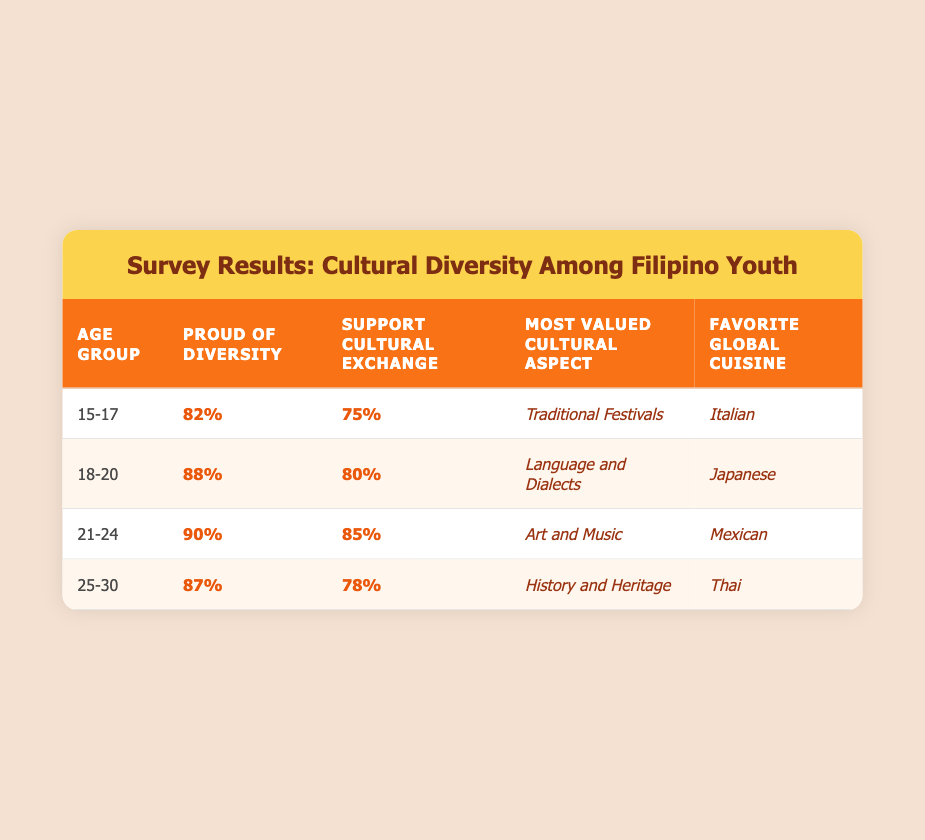What percentage of the 18-20 age group feel proud of diversity? In the table, for the age group 18-20, the corresponding percentage for feeling proud of diversity is listed. It shows 88%.
Answer: 88% What is the most valued cultural aspect among the 21-24 age group? By looking at the row for the 21-24 age group, we find that the most valued cultural aspect is "Art and Music."
Answer: Art and Music What percentage of Filipino youth aged 25-30 support cultural exchange? The table indicates that 78% of the 25-30 age group support cultural exchange.
Answer: 78% Which age group has the highest percentage of youths who feel proud of diversity? When examining the percentages for pride in diversity across all age groups, the 21-24 age group has the highest percentage, which is 90%.
Answer: 21-24 What is the favorite global cuisine for the 15-17 age group, and what percentage of them support cultural exchange? The favorite global cuisine for the 15-17 age group is "Italian," and the percentage who support cultural exchange is 75%.
Answer: Italian, 75% What is the difference in the percentage of those who support cultural exchange between the 18-20 and 21-24 age groups? The percentage supporting cultural exchange for 18-20 is 80%, and for 21-24 it is 85%. The difference is calculated as 85 - 80 = 5.
Answer: 5% If we take the average percentage of youth feeling proud of diversity across all age groups, what do we get? The percentages for feeling proud of diversity are 82%, 88%, 90%, and 87%. Summing these gives us 82 + 88 + 90 + 87 = 347. There are 4 age groups, so the average is 347 / 4 = 86.75%.
Answer: 86.75% Is the most valued cultural aspect for the 25-30 age group aligned with the favorite global cuisine for the same group? The most valued cultural aspect for the 25-30 age group is "History and Heritage," while the favorite global cuisine is "Thai." Since these do not match, the answer is no.
Answer: No Which age group has the highest support for cultural exchange, and by how much does it exceed the lowest? The highest support for cultural exchange is by the 21-24 age group at 85%, and the lowest is 75% from the 15-17 age group. The difference is 85 - 75 = 10%.
Answer: 21-24, 10% What cultural aspect do the majority of the youth aged 15-17 value the most, and how does it compare to those aged 25-30? The most valued cultural aspect for the 15-17 age group is "Traditional Festivals," while for 25-30, it is "History and Heritage." Both are different aspects, so they aren't directly comparable in value.
Answer: Different aspects 